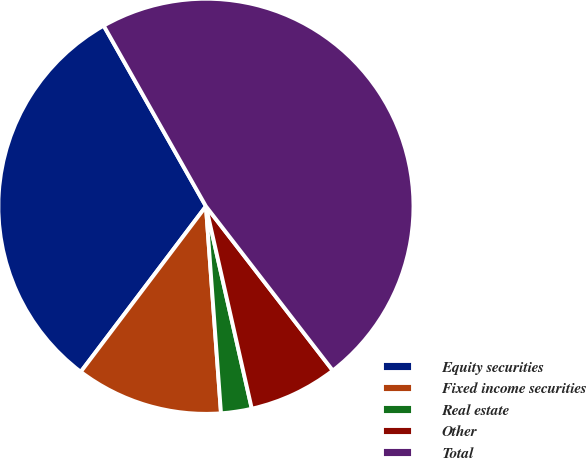<chart> <loc_0><loc_0><loc_500><loc_500><pie_chart><fcel>Equity securities<fcel>Fixed income securities<fcel>Real estate<fcel>Other<fcel>Total<nl><fcel>31.5%<fcel>11.46%<fcel>2.39%<fcel>6.92%<fcel>47.73%<nl></chart> 